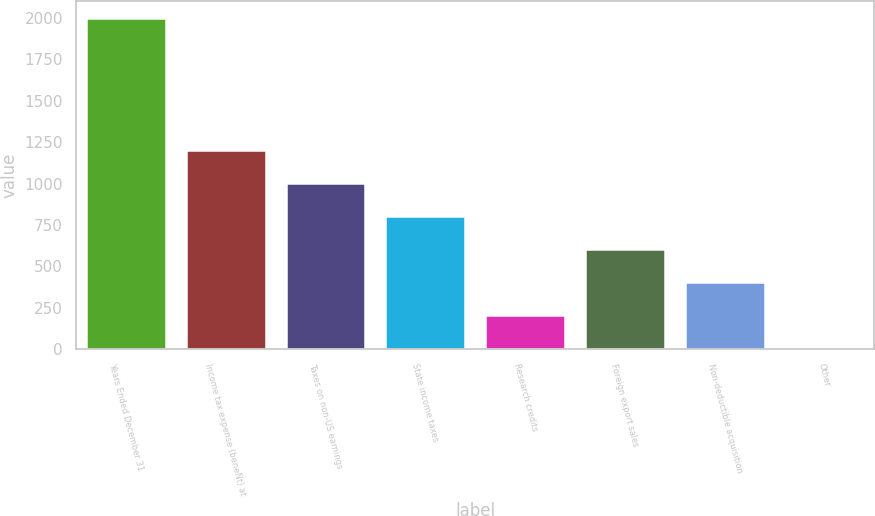Convert chart. <chart><loc_0><loc_0><loc_500><loc_500><bar_chart><fcel>Years Ended December 31<fcel>Income tax expense (beneÑt) at<fcel>Taxes on non-US earnings<fcel>State income taxes<fcel>Research credits<fcel>Foreign export sales<fcel>Non-deductible acquisition<fcel>Other<nl><fcel>2003<fcel>1204.6<fcel>1005<fcel>805.4<fcel>206.6<fcel>605.8<fcel>406.2<fcel>7<nl></chart> 